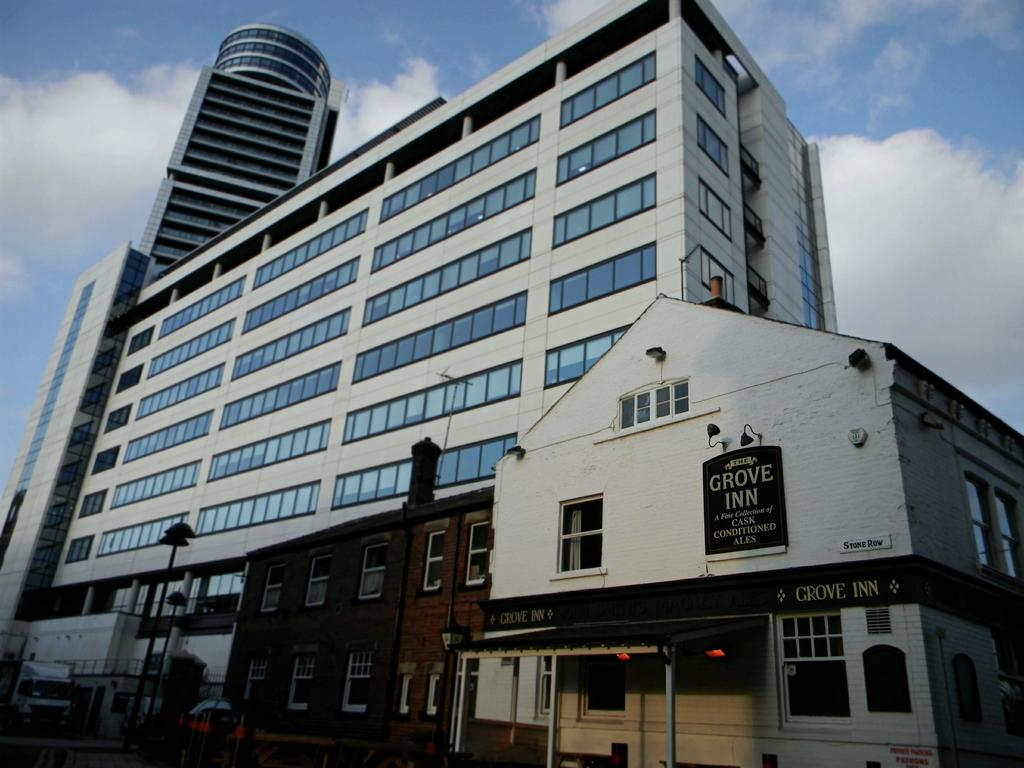What type of structures can be seen in the image? There are buildings with windows in the image. What else can be seen in the image besides buildings? There are poles and vehicles in the image. What is visible in the background of the image? The sky is visible in the background of the image. What can be observed in the sky? Clouds are present in the sky. What type of rifle is being used by the person in the image? There is no person or rifle present in the image. What type of canvas is being used to create the artwork in the image? There is no artwork or canvas present in the image. 